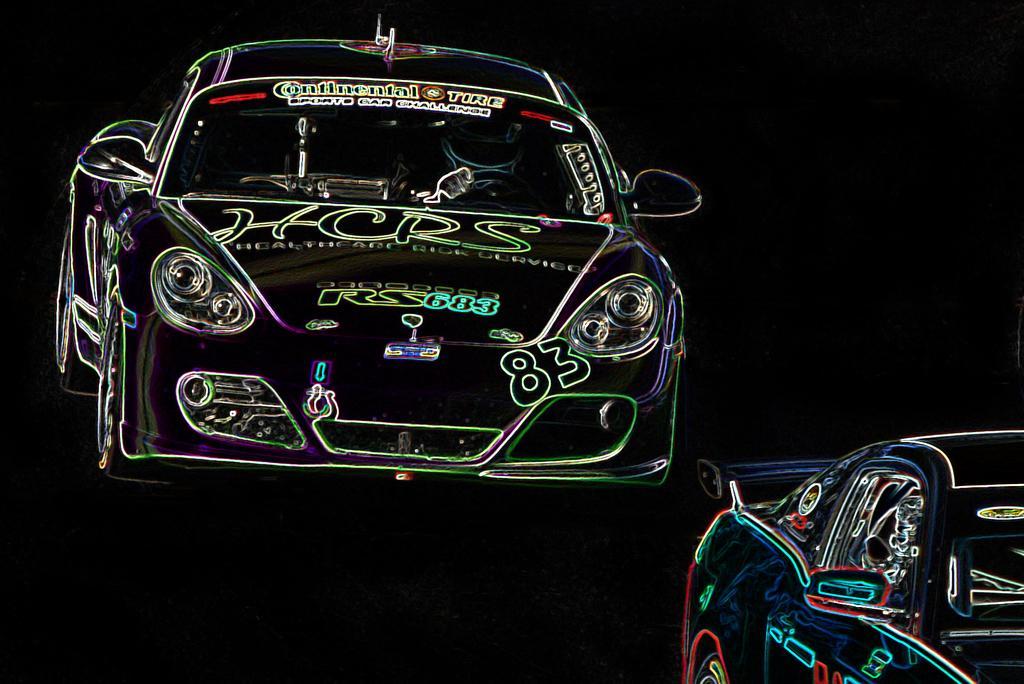How would you summarize this image in a sentence or two? In this image there is an animation of two cars. 